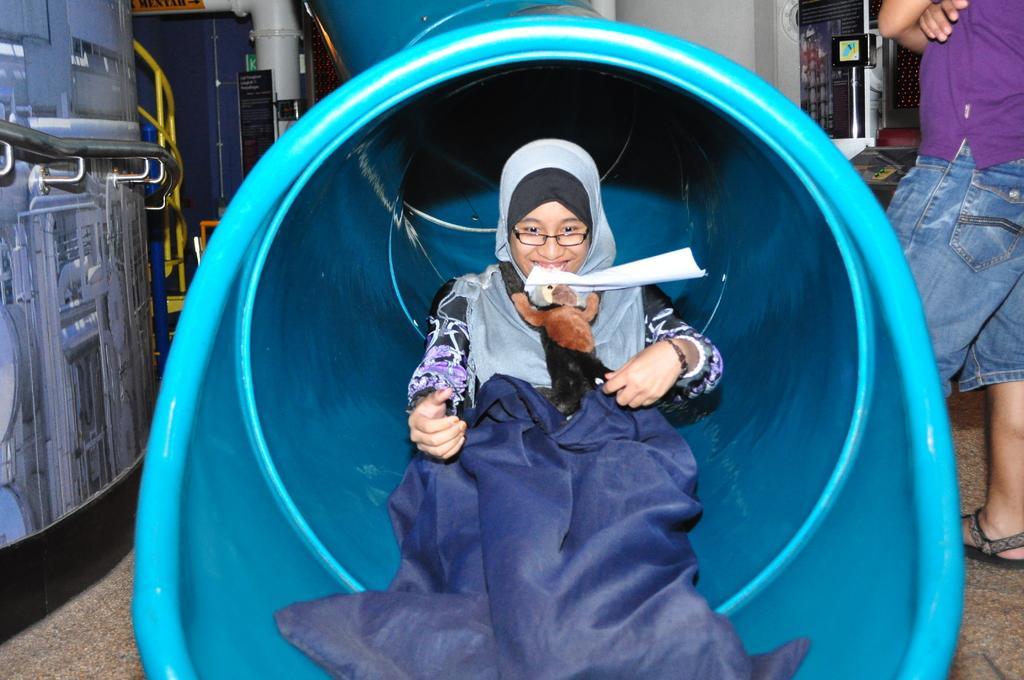Can you describe this image briefly? In the image there is an arab girl holding a teddy bear inside a pipe, on right side there is a man standing, on left side it seems to be a machine. 